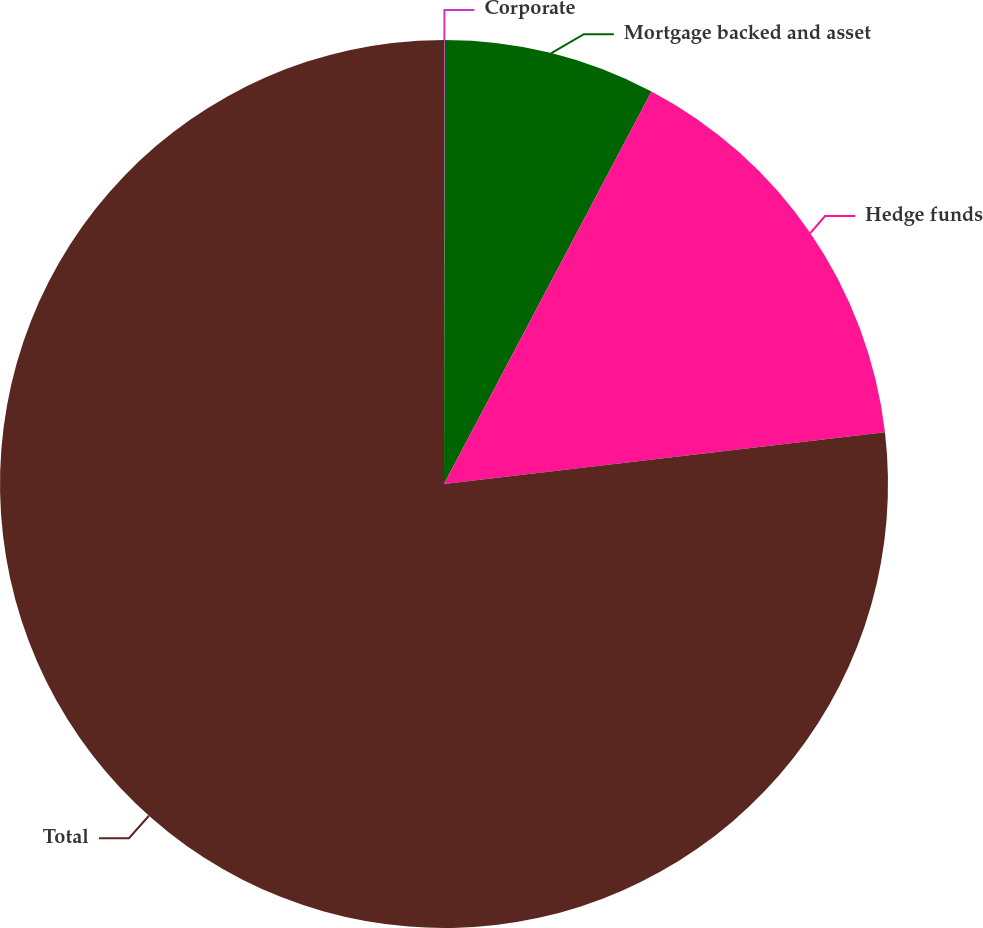<chart> <loc_0><loc_0><loc_500><loc_500><pie_chart><fcel>Corporate<fcel>Mortgage backed and asset<fcel>Hedge funds<fcel>Total<nl><fcel>0.03%<fcel>7.71%<fcel>15.4%<fcel>76.86%<nl></chart> 